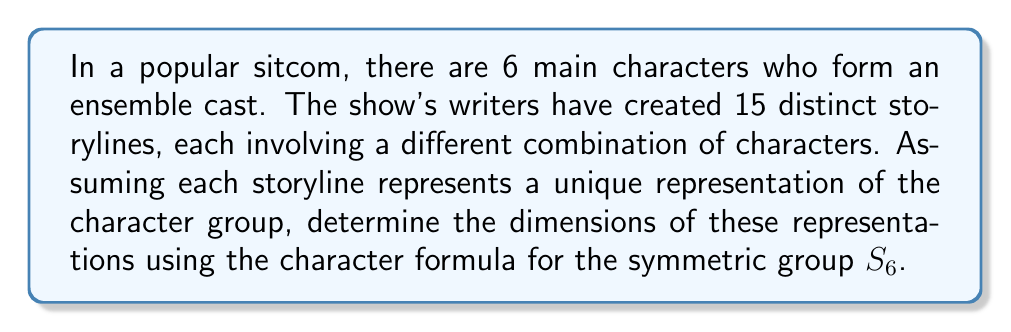Show me your answer to this math problem. To solve this problem, we'll follow these steps:

1) First, recall that the number of irreducible representations of the symmetric group $S_n$ is equal to the number of partitions of $n$. In this case, we have $S_6$.

2) The partitions of 6 are: [6], [5,1], [4,2], [4,1,1], [3,3], [3,2,1], [3,1,1,1], [2,2,2], [2,2,1,1], [2,1,1,1,1], [1,1,1,1,1,1].

3) Each of these partitions corresponds to a Young diagram, and the dimension of each representation is given by the hook length formula:

   $$\dim(\lambda) = \frac{n!}{\prod_{(i,j)\in\lambda} h_{ij}}$$

   where $h_{ij}$ is the hook length of the box $(i,j)$ in the Young diagram.

4) Let's calculate the dimensions for each partition:

   [6]: $\frac{6!}{6} = 1$
   [5,1]: $\frac{6!}{5 \cdot 1} = 5$
   [4,2]: $\frac{6!}{4 \cdot 2 \cdot 1} = 9$
   [4,1,1]: $\frac{6!}{4 \cdot 2 \cdot 1} = 10$
   [3,3]: $\frac{6!}{3 \cdot 2 \cdot 3 \cdot 1} = 5$
   [3,2,1]: $\frac{6!}{3 \cdot 2 \cdot 1 \cdot 2 \cdot 1} = 16$
   [3,1,1,1]: $\frac{6!}{3 \cdot 2 \cdot 1 \cdot 1} = 10$
   [2,2,2]: $\frac{6!}{2 \cdot 1 \cdot 2 \cdot 1 \cdot 2 \cdot 1} = 5$
   [2,2,1,1]: $\frac{6!}{2 \cdot 1 \cdot 2 \cdot 1 \cdot 1} = 9$
   [2,1,1,1,1]: $\frac{6!}{2 \cdot 1 \cdot 1 \cdot 1 \cdot 1} = 5$
   [1,1,1,1,1,1]: $\frac{6!}{1 \cdot 1 \cdot 1 \cdot 1 \cdot 1 \cdot 1} = 1$

5) The 15 distinct storylines correspond to the 15 distinct representations of $S_6$, which are the 11 irreducible representations we just calculated.
Answer: $1, 5, 9, 10, 5, 16, 10, 5, 9, 5, 1$ 